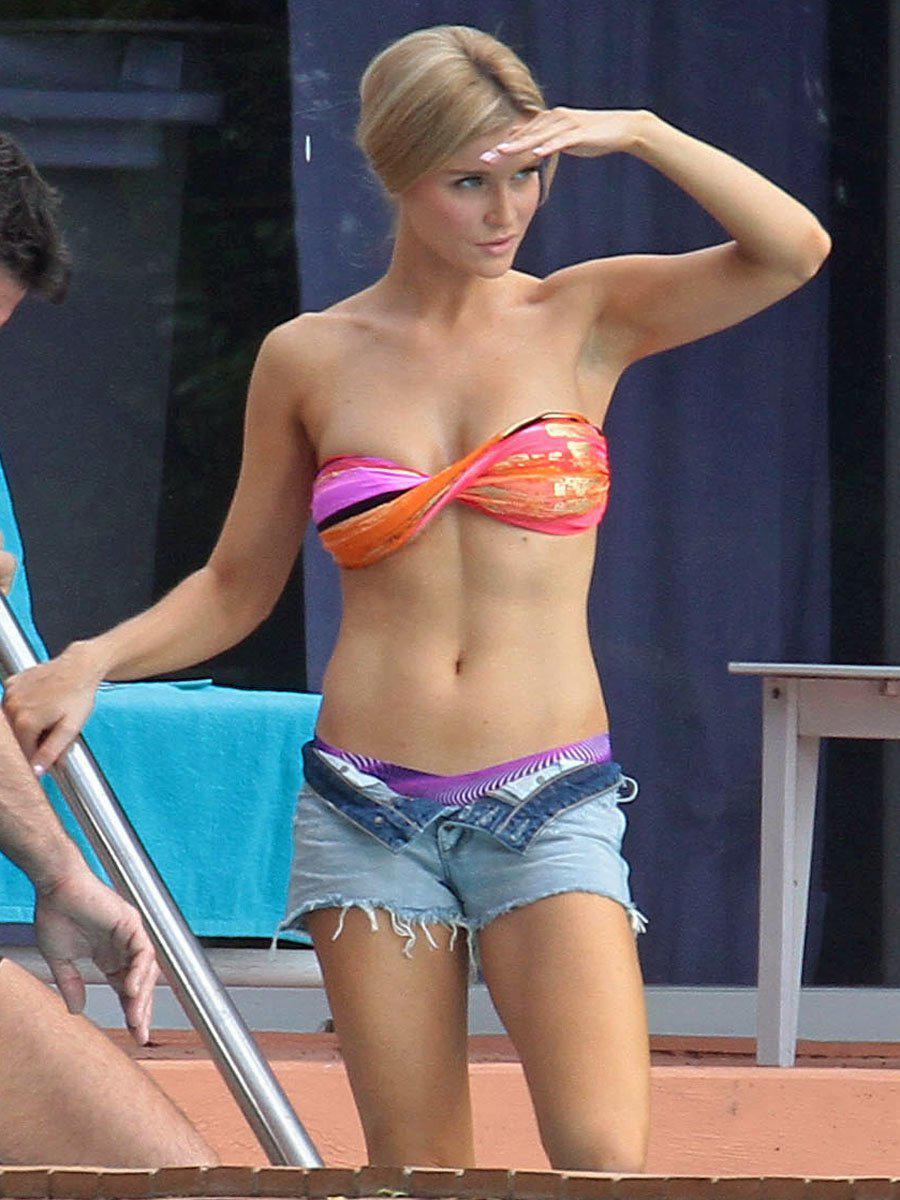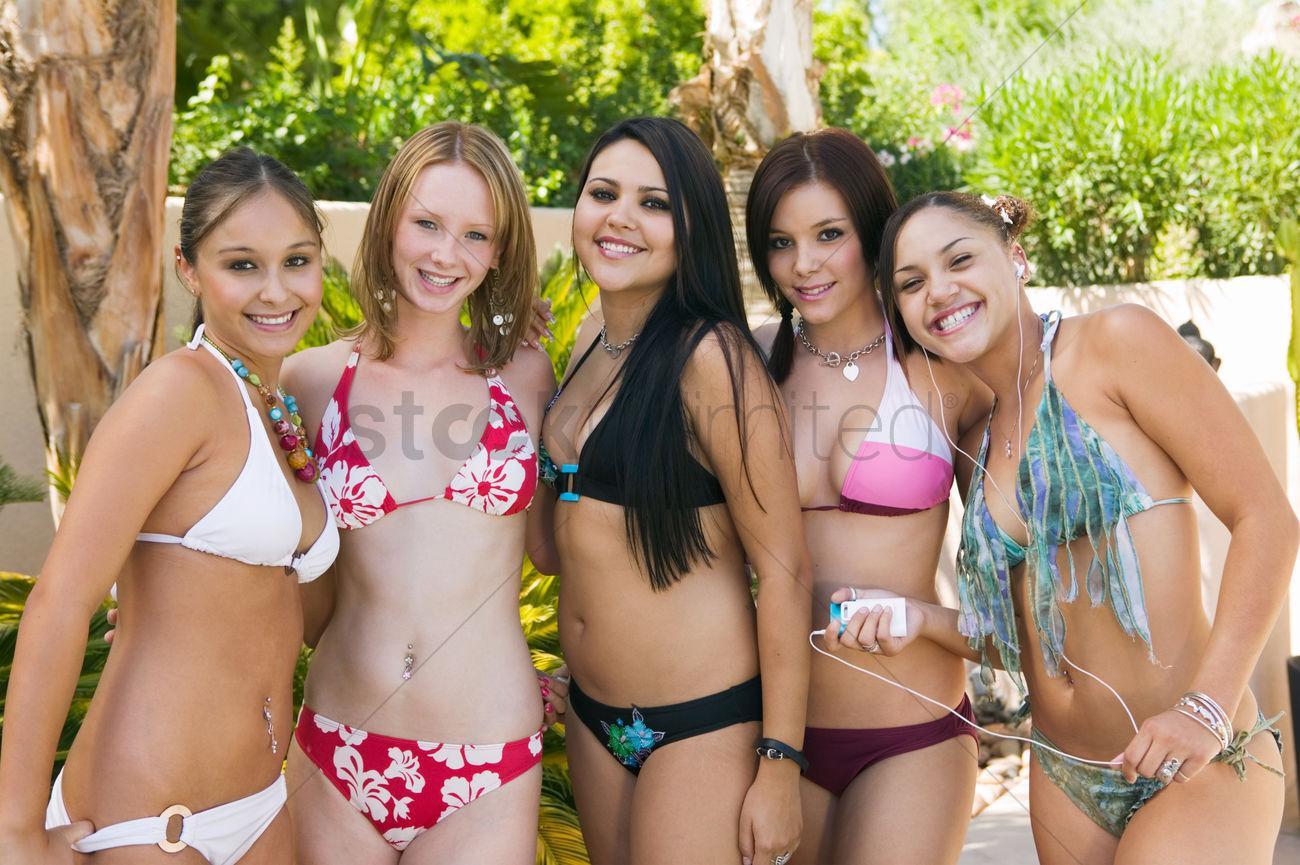The first image is the image on the left, the second image is the image on the right. Evaluate the accuracy of this statement regarding the images: "An image shows one model wearing a twisted bikini top and denim shorts.". Is it true? Answer yes or no. Yes. The first image is the image on the left, the second image is the image on the right. Assess this claim about the two images: "A woman is wearing a predominantly orange swimsuit and denim shorts.". Correct or not? Answer yes or no. Yes. 